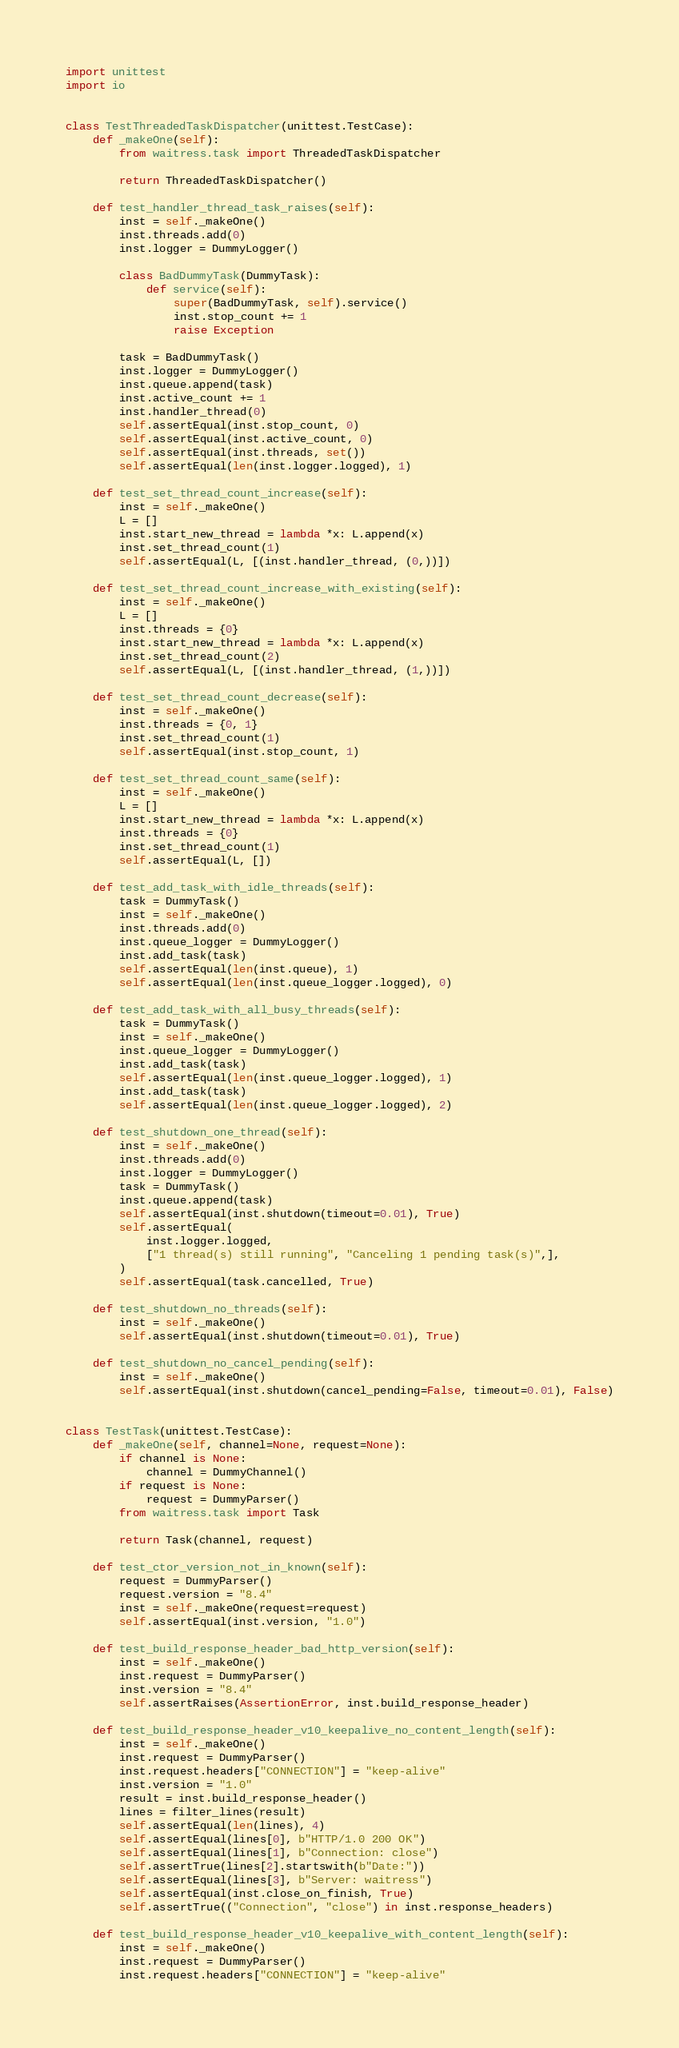Convert code to text. <code><loc_0><loc_0><loc_500><loc_500><_Python_>import unittest
import io


class TestThreadedTaskDispatcher(unittest.TestCase):
    def _makeOne(self):
        from waitress.task import ThreadedTaskDispatcher

        return ThreadedTaskDispatcher()

    def test_handler_thread_task_raises(self):
        inst = self._makeOne()
        inst.threads.add(0)
        inst.logger = DummyLogger()

        class BadDummyTask(DummyTask):
            def service(self):
                super(BadDummyTask, self).service()
                inst.stop_count += 1
                raise Exception

        task = BadDummyTask()
        inst.logger = DummyLogger()
        inst.queue.append(task)
        inst.active_count += 1
        inst.handler_thread(0)
        self.assertEqual(inst.stop_count, 0)
        self.assertEqual(inst.active_count, 0)
        self.assertEqual(inst.threads, set())
        self.assertEqual(len(inst.logger.logged), 1)

    def test_set_thread_count_increase(self):
        inst = self._makeOne()
        L = []
        inst.start_new_thread = lambda *x: L.append(x)
        inst.set_thread_count(1)
        self.assertEqual(L, [(inst.handler_thread, (0,))])

    def test_set_thread_count_increase_with_existing(self):
        inst = self._makeOne()
        L = []
        inst.threads = {0}
        inst.start_new_thread = lambda *x: L.append(x)
        inst.set_thread_count(2)
        self.assertEqual(L, [(inst.handler_thread, (1,))])

    def test_set_thread_count_decrease(self):
        inst = self._makeOne()
        inst.threads = {0, 1}
        inst.set_thread_count(1)
        self.assertEqual(inst.stop_count, 1)

    def test_set_thread_count_same(self):
        inst = self._makeOne()
        L = []
        inst.start_new_thread = lambda *x: L.append(x)
        inst.threads = {0}
        inst.set_thread_count(1)
        self.assertEqual(L, [])

    def test_add_task_with_idle_threads(self):
        task = DummyTask()
        inst = self._makeOne()
        inst.threads.add(0)
        inst.queue_logger = DummyLogger()
        inst.add_task(task)
        self.assertEqual(len(inst.queue), 1)
        self.assertEqual(len(inst.queue_logger.logged), 0)

    def test_add_task_with_all_busy_threads(self):
        task = DummyTask()
        inst = self._makeOne()
        inst.queue_logger = DummyLogger()
        inst.add_task(task)
        self.assertEqual(len(inst.queue_logger.logged), 1)
        inst.add_task(task)
        self.assertEqual(len(inst.queue_logger.logged), 2)

    def test_shutdown_one_thread(self):
        inst = self._makeOne()
        inst.threads.add(0)
        inst.logger = DummyLogger()
        task = DummyTask()
        inst.queue.append(task)
        self.assertEqual(inst.shutdown(timeout=0.01), True)
        self.assertEqual(
            inst.logger.logged,
            ["1 thread(s) still running", "Canceling 1 pending task(s)",],
        )
        self.assertEqual(task.cancelled, True)

    def test_shutdown_no_threads(self):
        inst = self._makeOne()
        self.assertEqual(inst.shutdown(timeout=0.01), True)

    def test_shutdown_no_cancel_pending(self):
        inst = self._makeOne()
        self.assertEqual(inst.shutdown(cancel_pending=False, timeout=0.01), False)


class TestTask(unittest.TestCase):
    def _makeOne(self, channel=None, request=None):
        if channel is None:
            channel = DummyChannel()
        if request is None:
            request = DummyParser()
        from waitress.task import Task

        return Task(channel, request)

    def test_ctor_version_not_in_known(self):
        request = DummyParser()
        request.version = "8.4"
        inst = self._makeOne(request=request)
        self.assertEqual(inst.version, "1.0")

    def test_build_response_header_bad_http_version(self):
        inst = self._makeOne()
        inst.request = DummyParser()
        inst.version = "8.4"
        self.assertRaises(AssertionError, inst.build_response_header)

    def test_build_response_header_v10_keepalive_no_content_length(self):
        inst = self._makeOne()
        inst.request = DummyParser()
        inst.request.headers["CONNECTION"] = "keep-alive"
        inst.version = "1.0"
        result = inst.build_response_header()
        lines = filter_lines(result)
        self.assertEqual(len(lines), 4)
        self.assertEqual(lines[0], b"HTTP/1.0 200 OK")
        self.assertEqual(lines[1], b"Connection: close")
        self.assertTrue(lines[2].startswith(b"Date:"))
        self.assertEqual(lines[3], b"Server: waitress")
        self.assertEqual(inst.close_on_finish, True)
        self.assertTrue(("Connection", "close") in inst.response_headers)

    def test_build_response_header_v10_keepalive_with_content_length(self):
        inst = self._makeOne()
        inst.request = DummyParser()
        inst.request.headers["CONNECTION"] = "keep-alive"</code> 